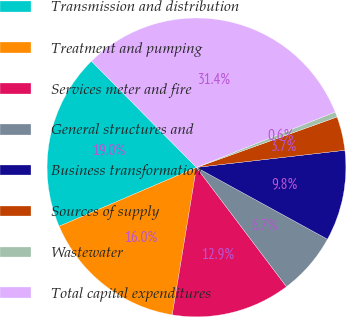Convert chart. <chart><loc_0><loc_0><loc_500><loc_500><pie_chart><fcel>Transmission and distribution<fcel>Treatment and pumping<fcel>Services meter and fire<fcel>General structures and<fcel>Business transformation<fcel>Sources of supply<fcel>Wastewater<fcel>Total capital expenditures<nl><fcel>19.04%<fcel>15.96%<fcel>12.88%<fcel>6.73%<fcel>9.81%<fcel>3.65%<fcel>0.57%<fcel>31.35%<nl></chart> 